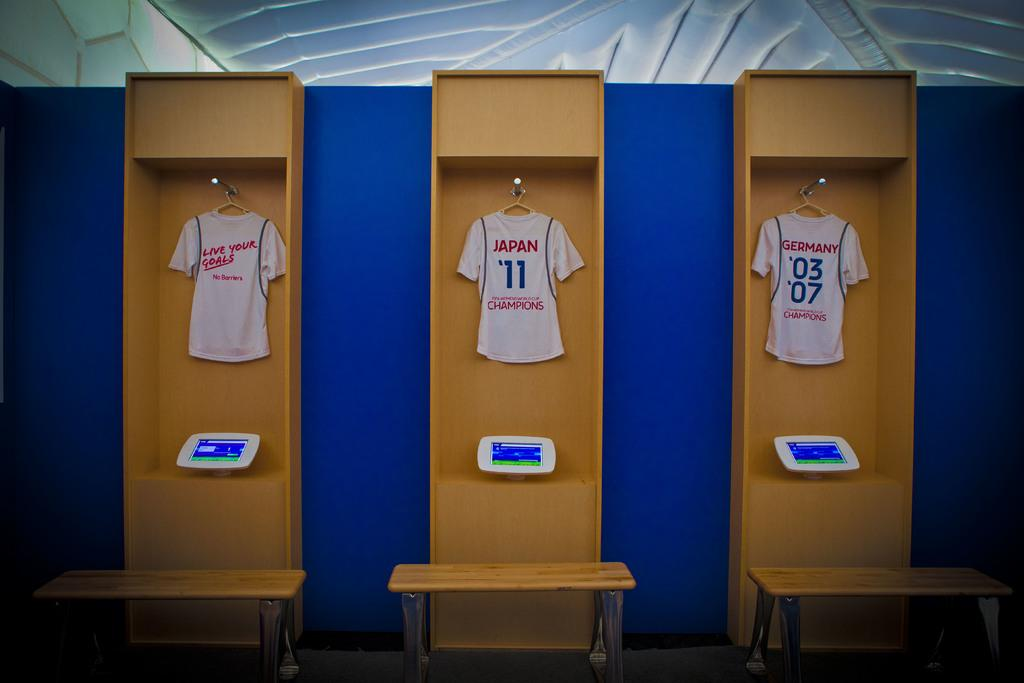<image>
Create a compact narrative representing the image presented. Three shirts saying "Live your goals", "Japan '11", and "Germany '03 '07" are displayed hanging in wood cases. 